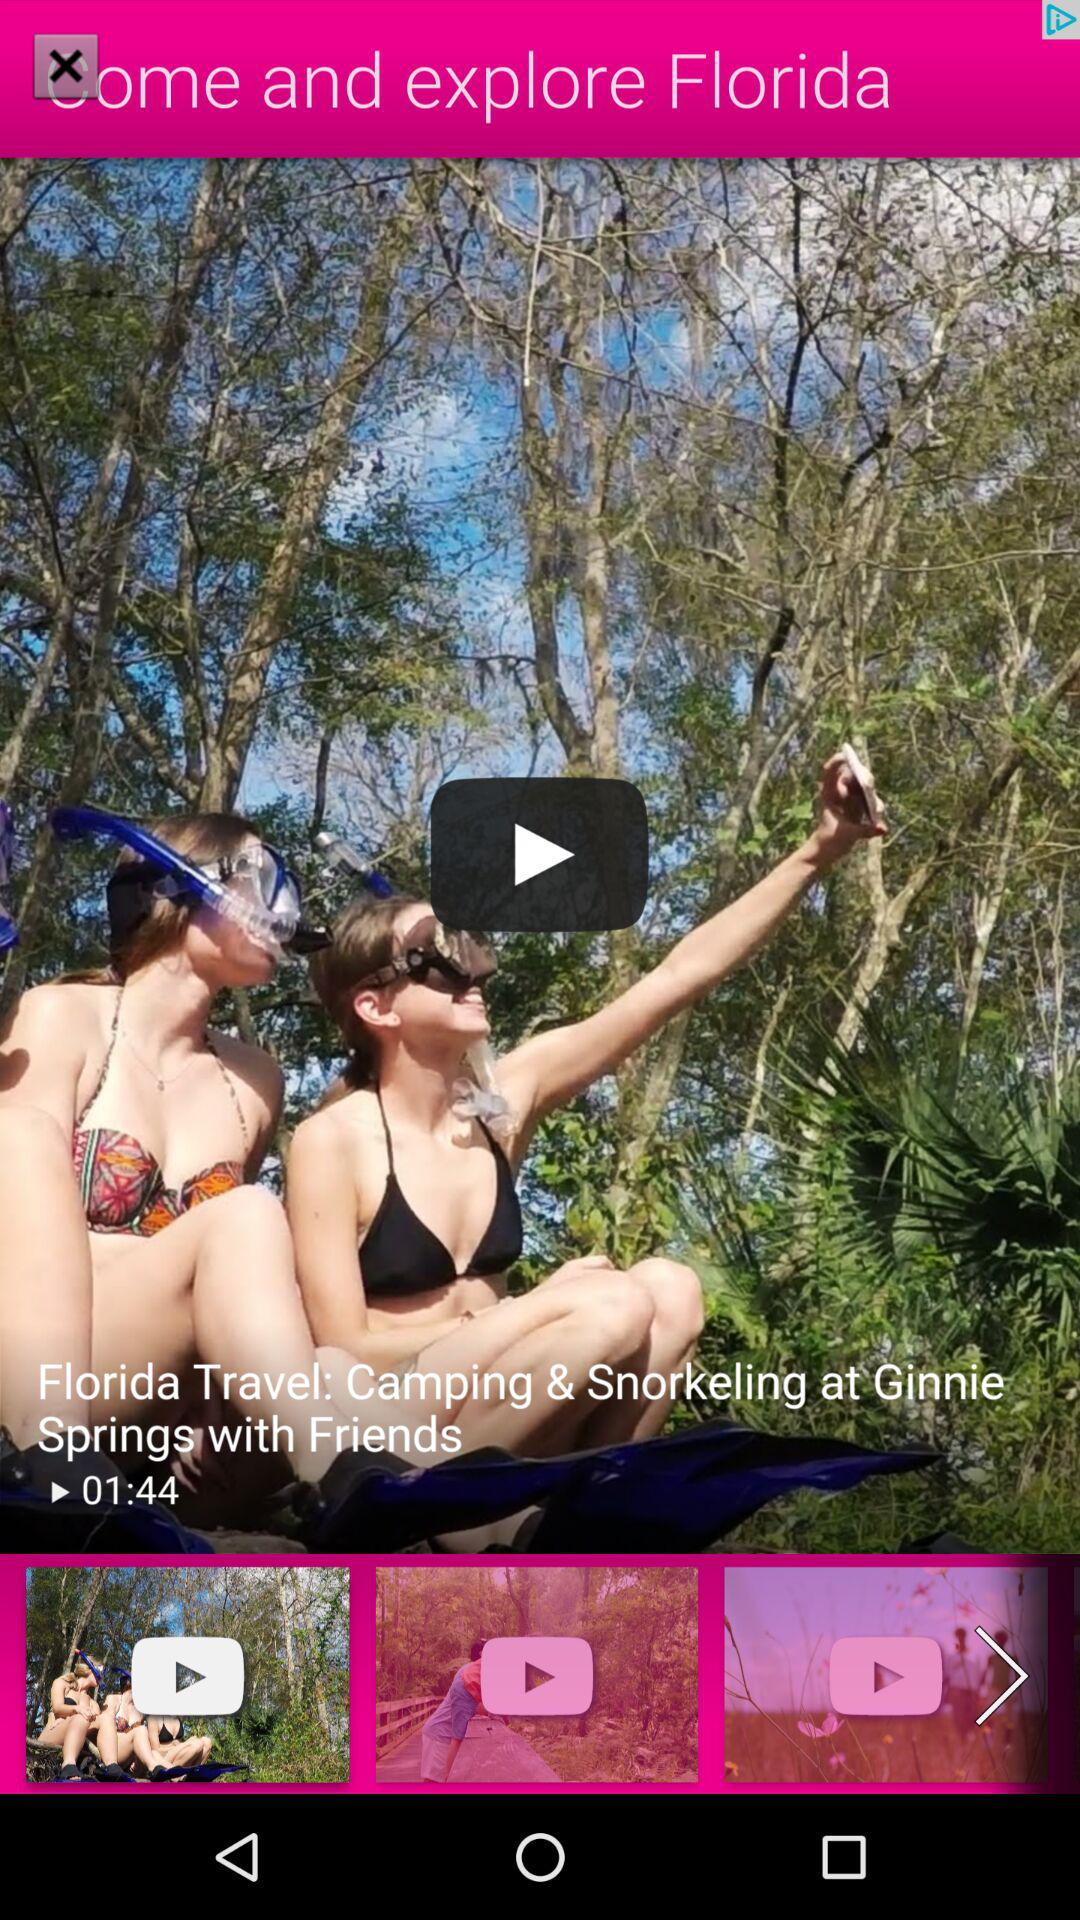What is the time duration? The time duration is 1 minute 44 seconds. 